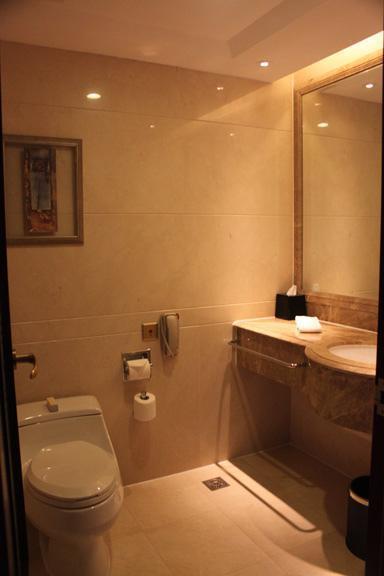How many flowers are in the bathroom?
Give a very brief answer. 0. How many toilets are in the photo?
Give a very brief answer. 1. 